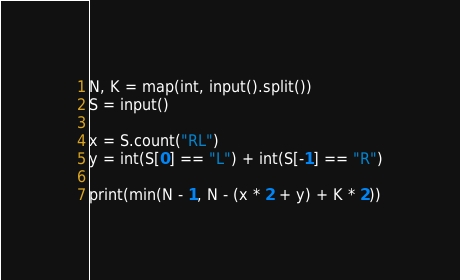Convert code to text. <code><loc_0><loc_0><loc_500><loc_500><_Python_>N, K = map(int, input().split())
S = input()

x = S.count("RL")
y = int(S[0] == "L") + int(S[-1] == "R")
    
print(min(N - 1, N - (x * 2 + y) + K * 2))
</code> 